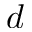<formula> <loc_0><loc_0><loc_500><loc_500>\, d</formula> 